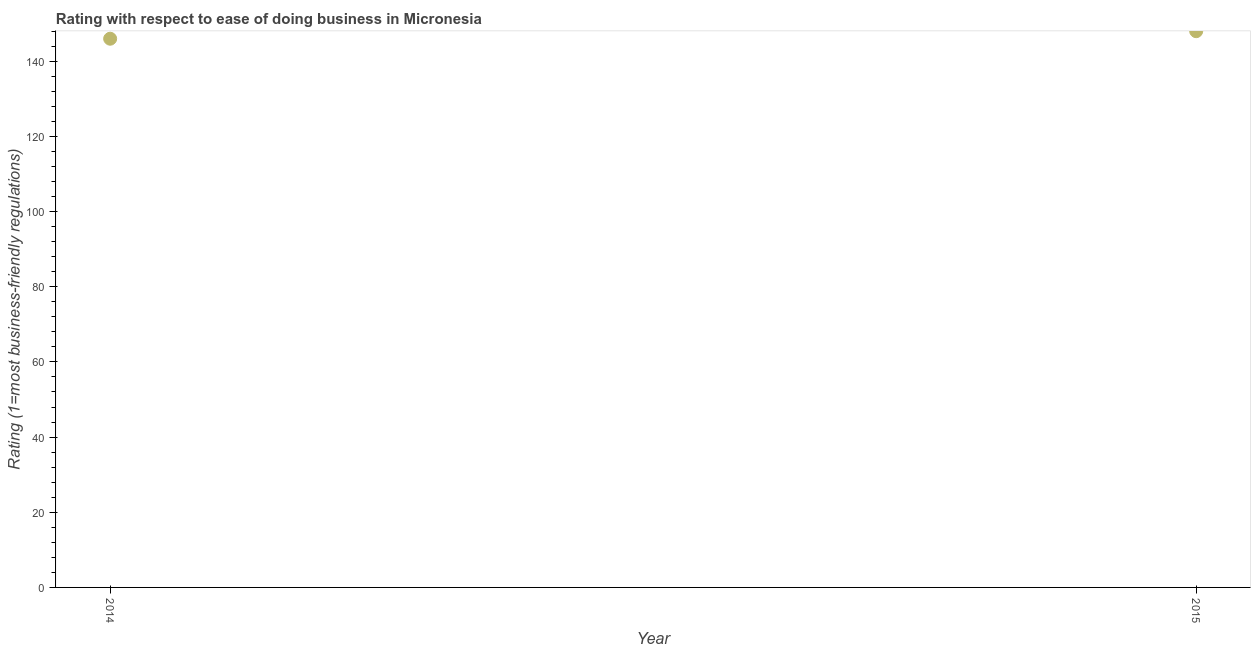What is the ease of doing business index in 2014?
Provide a short and direct response. 146. Across all years, what is the maximum ease of doing business index?
Your response must be concise. 148. Across all years, what is the minimum ease of doing business index?
Give a very brief answer. 146. In which year was the ease of doing business index maximum?
Your answer should be compact. 2015. In which year was the ease of doing business index minimum?
Make the answer very short. 2014. What is the sum of the ease of doing business index?
Your response must be concise. 294. What is the difference between the ease of doing business index in 2014 and 2015?
Offer a very short reply. -2. What is the average ease of doing business index per year?
Your answer should be compact. 147. What is the median ease of doing business index?
Keep it short and to the point. 147. In how many years, is the ease of doing business index greater than 56 ?
Make the answer very short. 2. What is the ratio of the ease of doing business index in 2014 to that in 2015?
Your answer should be very brief. 0.99. Is the ease of doing business index in 2014 less than that in 2015?
Make the answer very short. Yes. Does the ease of doing business index monotonically increase over the years?
Provide a short and direct response. Yes. How many years are there in the graph?
Your answer should be very brief. 2. What is the difference between two consecutive major ticks on the Y-axis?
Ensure brevity in your answer.  20. What is the title of the graph?
Provide a succinct answer. Rating with respect to ease of doing business in Micronesia. What is the label or title of the X-axis?
Offer a very short reply. Year. What is the label or title of the Y-axis?
Provide a short and direct response. Rating (1=most business-friendly regulations). What is the Rating (1=most business-friendly regulations) in 2014?
Your answer should be compact. 146. What is the Rating (1=most business-friendly regulations) in 2015?
Offer a very short reply. 148. What is the difference between the Rating (1=most business-friendly regulations) in 2014 and 2015?
Offer a terse response. -2. 